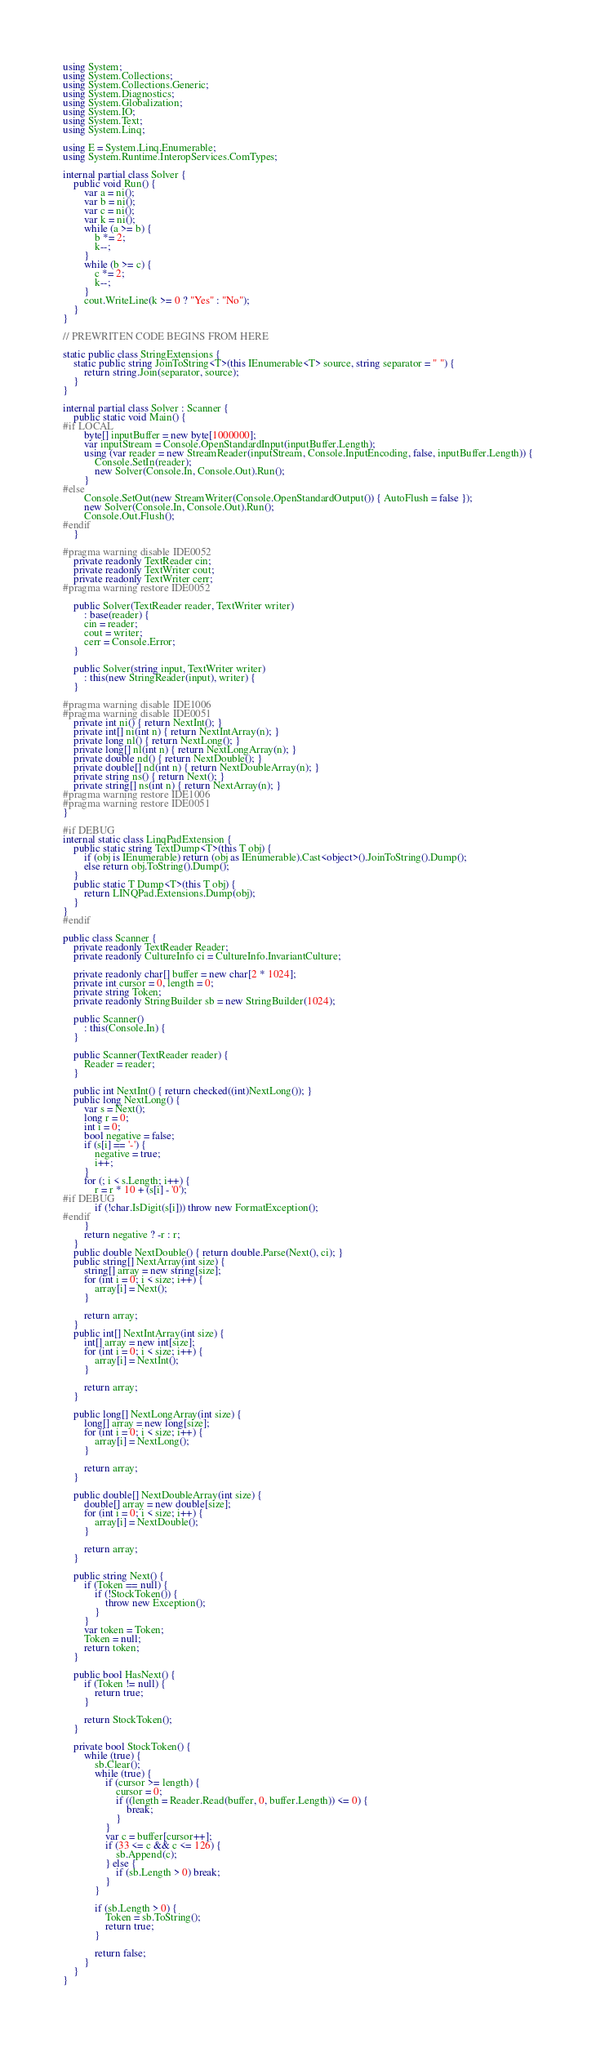<code> <loc_0><loc_0><loc_500><loc_500><_C#_>using System;
using System.Collections;
using System.Collections.Generic;
using System.Diagnostics;
using System.Globalization;
using System.IO;
using System.Text;
using System.Linq;

using E = System.Linq.Enumerable;
using System.Runtime.InteropServices.ComTypes;

internal partial class Solver {
    public void Run() {
        var a = ni();
        var b = ni();
        var c = ni();
        var k = ni();
        while (a >= b) {
            b *= 2;
            k--;
        }
        while (b >= c) {
            c *= 2;
            k--;
        }
        cout.WriteLine(k >= 0 ? "Yes" : "No");
    }
}

// PREWRITEN CODE BEGINS FROM HERE

static public class StringExtensions {
    static public string JoinToString<T>(this IEnumerable<T> source, string separator = " ") {
        return string.Join(separator, source);
    }
}

internal partial class Solver : Scanner {
    public static void Main() {
#if LOCAL
        byte[] inputBuffer = new byte[1000000];
        var inputStream = Console.OpenStandardInput(inputBuffer.Length);
        using (var reader = new StreamReader(inputStream, Console.InputEncoding, false, inputBuffer.Length)) {
            Console.SetIn(reader);
            new Solver(Console.In, Console.Out).Run();
        }
#else
        Console.SetOut(new StreamWriter(Console.OpenStandardOutput()) { AutoFlush = false });
        new Solver(Console.In, Console.Out).Run();
        Console.Out.Flush();
#endif
    }

#pragma warning disable IDE0052
    private readonly TextReader cin;
    private readonly TextWriter cout;
    private readonly TextWriter cerr;
#pragma warning restore IDE0052

    public Solver(TextReader reader, TextWriter writer)
        : base(reader) {
        cin = reader;
        cout = writer;
        cerr = Console.Error;
    }

    public Solver(string input, TextWriter writer)
        : this(new StringReader(input), writer) {
    }

#pragma warning disable IDE1006
#pragma warning disable IDE0051
    private int ni() { return NextInt(); }
    private int[] ni(int n) { return NextIntArray(n); }
    private long nl() { return NextLong(); }
    private long[] nl(int n) { return NextLongArray(n); }
    private double nd() { return NextDouble(); }
    private double[] nd(int n) { return NextDoubleArray(n); }
    private string ns() { return Next(); }
    private string[] ns(int n) { return NextArray(n); }
#pragma warning restore IDE1006
#pragma warning restore IDE0051
}

#if DEBUG
internal static class LinqPadExtension {
    public static string TextDump<T>(this T obj) {
        if (obj is IEnumerable) return (obj as IEnumerable).Cast<object>().JoinToString().Dump();
        else return obj.ToString().Dump();
    }
    public static T Dump<T>(this T obj) {
        return LINQPad.Extensions.Dump(obj);
    }
}
#endif

public class Scanner {
    private readonly TextReader Reader;
    private readonly CultureInfo ci = CultureInfo.InvariantCulture;

    private readonly char[] buffer = new char[2 * 1024];
    private int cursor = 0, length = 0;
    private string Token;
    private readonly StringBuilder sb = new StringBuilder(1024);

    public Scanner()
        : this(Console.In) {
    }

    public Scanner(TextReader reader) {
        Reader = reader;
    }

    public int NextInt() { return checked((int)NextLong()); }
    public long NextLong() {
        var s = Next();
        long r = 0;
        int i = 0;
        bool negative = false;
        if (s[i] == '-') {
            negative = true;
            i++;
        }
        for (; i < s.Length; i++) {
            r = r * 10 + (s[i] - '0');
#if DEBUG
            if (!char.IsDigit(s[i])) throw new FormatException();
#endif
        }
        return negative ? -r : r;
    }
    public double NextDouble() { return double.Parse(Next(), ci); }
    public string[] NextArray(int size) {
        string[] array = new string[size];
        for (int i = 0; i < size; i++) {
            array[i] = Next();
        }

        return array;
    }
    public int[] NextIntArray(int size) {
        int[] array = new int[size];
        for (int i = 0; i < size; i++) {
            array[i] = NextInt();
        }

        return array;
    }

    public long[] NextLongArray(int size) {
        long[] array = new long[size];
        for (int i = 0; i < size; i++) {
            array[i] = NextLong();
        }

        return array;
    }

    public double[] NextDoubleArray(int size) {
        double[] array = new double[size];
        for (int i = 0; i < size; i++) {
            array[i] = NextDouble();
        }

        return array;
    }

    public string Next() {
        if (Token == null) {
            if (!StockToken()) {
                throw new Exception();
            }
        }
        var token = Token;
        Token = null;
        return token;
    }

    public bool HasNext() {
        if (Token != null) {
            return true;
        }

        return StockToken();
    }

    private bool StockToken() {
        while (true) {
            sb.Clear();
            while (true) {
                if (cursor >= length) {
                    cursor = 0;
                    if ((length = Reader.Read(buffer, 0, buffer.Length)) <= 0) {
                        break;
                    }
                }
                var c = buffer[cursor++];
                if (33 <= c && c <= 126) {
                    sb.Append(c);
                } else {
                    if (sb.Length > 0) break;
                }
            }

            if (sb.Length > 0) {
                Token = sb.ToString();
                return true;
            }

            return false;
        }
    }
}</code> 